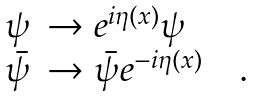<formula> <loc_0><loc_0><loc_500><loc_500>\begin{array} { l l } \psi & \rightarrow e ^ { i \eta ( x ) } \psi \\ \bar { \psi } & \rightarrow \bar { \psi } e ^ { - i \eta ( x ) } \quad . \end{array}</formula> 